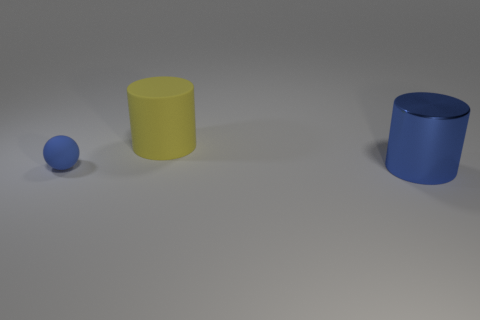Is there anything else that has the same material as the big blue cylinder?
Make the answer very short. No. Are the yellow thing and the big blue cylinder made of the same material?
Offer a very short reply. No. What number of spheres are green objects or blue matte things?
Provide a short and direct response. 1. What is the color of the cylinder that is to the left of the cylinder that is in front of the blue sphere?
Provide a short and direct response. Yellow. What size is the cylinder that is the same color as the tiny thing?
Offer a terse response. Large. How many blue cylinders are to the left of the big thing that is in front of the ball in front of the yellow cylinder?
Your answer should be compact. 0. Does the matte thing on the right side of the blue rubber sphere have the same shape as the big object right of the big rubber object?
Your answer should be compact. Yes. What number of objects are either large gray blocks or large yellow cylinders?
Your answer should be very brief. 1. What is the large thing right of the cylinder that is behind the tiny blue matte sphere made of?
Your answer should be very brief. Metal. Is there a small rubber object of the same color as the large metal cylinder?
Offer a terse response. Yes. 